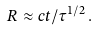Convert formula to latex. <formula><loc_0><loc_0><loc_500><loc_500>R \approx c t / \tau ^ { 1 / 2 } \, .</formula> 